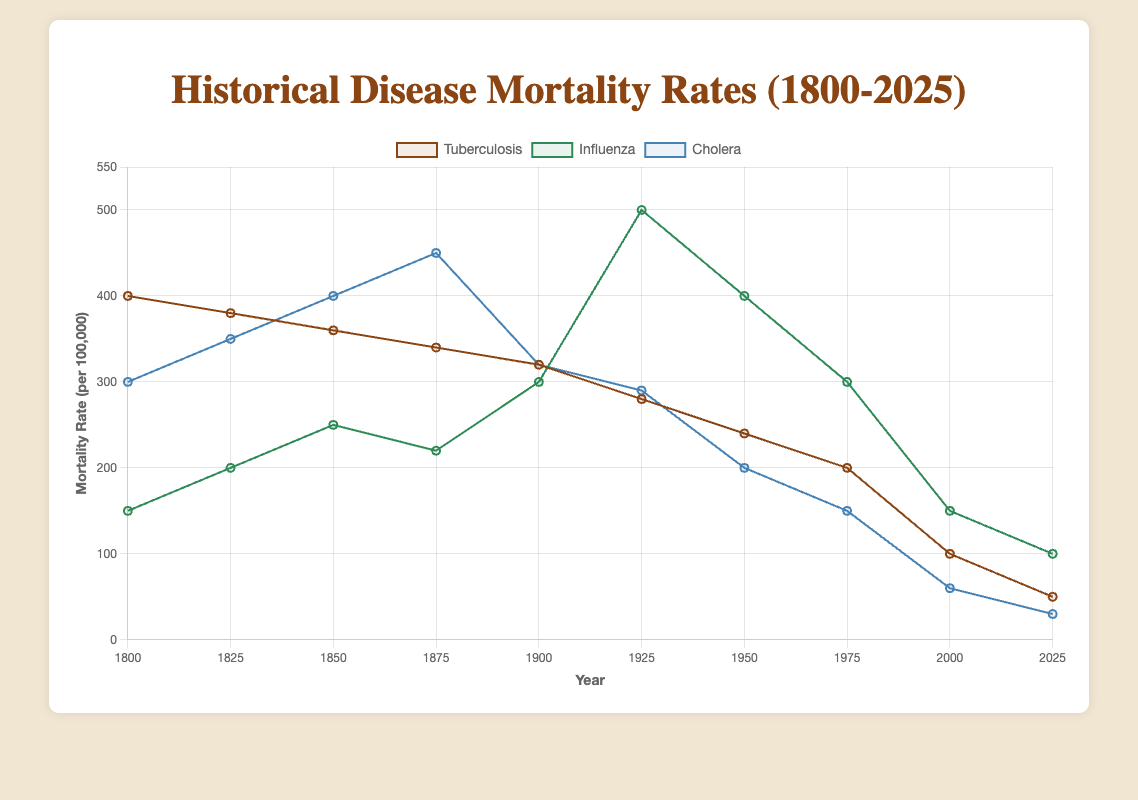Which disease had the highest mortality rate in 1925? Look at the values for the year 1925 and compare the mortality rates of tuberculosis, influenza, and cholera. The highest value is for influenza at 500 per 100,000
Answer: Influenza What is the total mortality rate for all three diseases in the year 2000? Add the mortality rates for tuberculosis, influenza, and cholera for the year 2000. The sum is 100 (tuberculosis) + 150 (influenza) + 60 (cholera) = 310 per 100,000
Answer: 310 How did the mortality rate of tuberculosis change from 1800 to 2025? Subtract the mortality rate of tuberculosis in 2025 from that in 1800. The change is 50 - 400 = -350 per 100,000, indicating a decrease
Answer: Decreased by 350 Which year saw the highest mortality rate for cholera and what was the rate? Find the year with the peak value for cholera mortality rates. The highest rate is in 1875 with a value of 450 per 100,000
Answer: 1875, 450 per 100,000 Between which two years did influenza see the largest increase in mortality rate? Compare the differences in mortality rates between consecutive years for influenza and identify the largest increase. The largest jump is from 1925 to 1950, increasing from 300 to 500 per 100,000, which is an increase of 200 per 100,000
Answer: Between 1900 and 1925 Comparing the year 1950, which disease had the closest mortality rate to cholera? Check the mortality rates for tuberculosis and influenza in 1950 and compare them with the rate for cholera (200 per 100,000). The mortality rate for tuberculosis (240 per 100,000) is closer than influenza (400 per 100,000)
Answer: Tuberculosis What is the difference between the highest and lowest mortality rates recorded for influenza throughout the given years? Determine the maximum and minimum mortality rates for influenza, which are 500 per 100,000 (in 1925) and 100 per 100,000 (in 2025), respectively. The difference is 500 - 100 = 400 per 100,000
Answer: 400 What is the average mortality rate of cholera over the entire period shown? Add up all the mortality rates for cholera and divide by the number of data points. The sum is 300 + 350 + 400 + 450 + 320 + 290 + 200 + 150 + 60 + 30 = 2550, and the average is 2550 / 10 = 255 per 100,000
Answer: 255 Which disease showed a steady decrease in mortality rate over time? Observing the trends in the data, tuberculosis shows a consistent decline in mortality rates from 1800 to 2025
Answer: Tuberculosis In which year did the mortality rate of influenza equal that of tuberculosis? Compare the mortality rates of influenza and tuberculosis across the years provided. Both rates are equal in the year 2000, with values of 150 per 100,000
Answer: 2000 